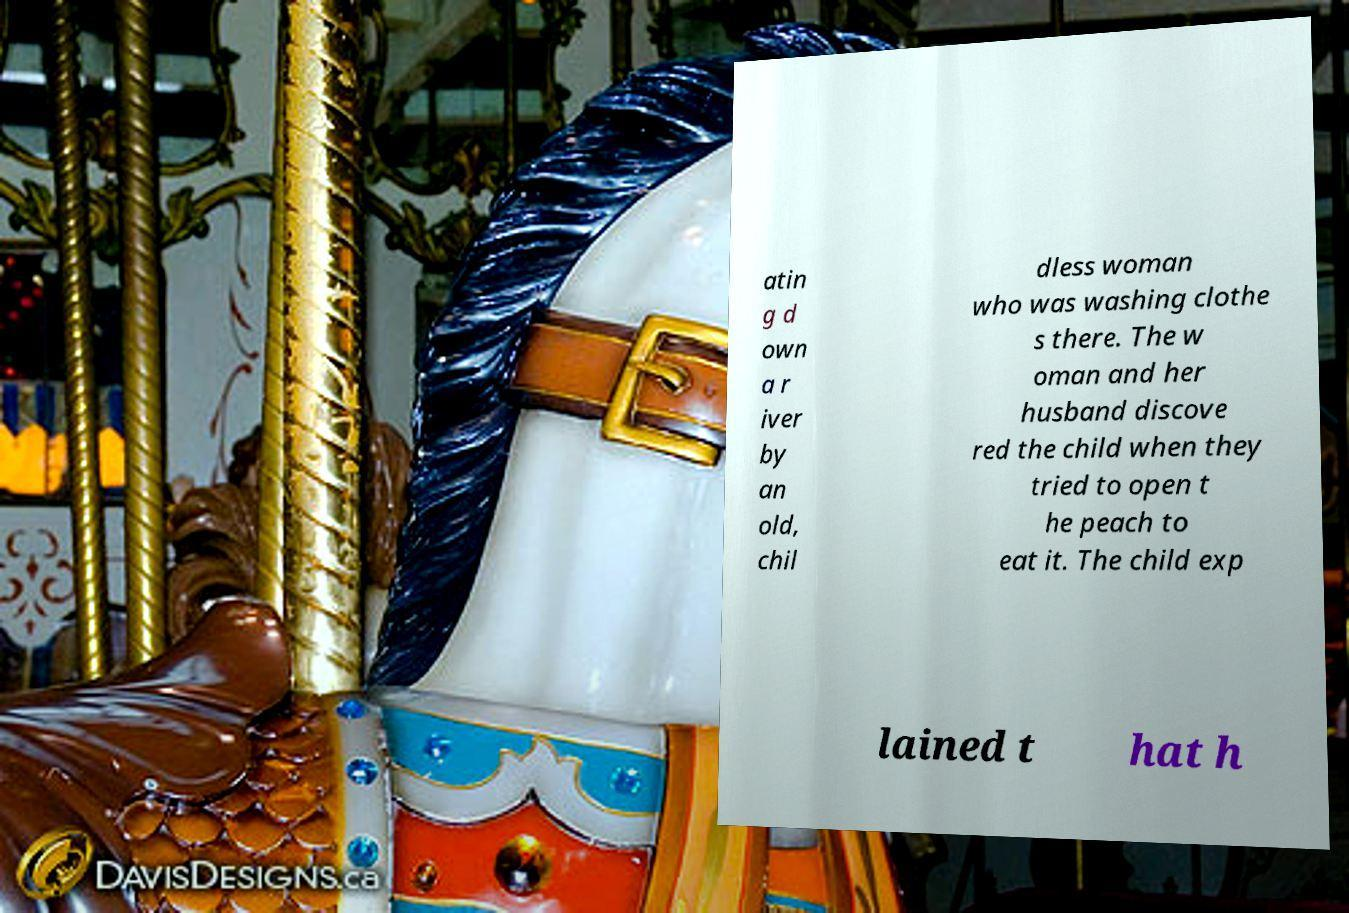Could you assist in decoding the text presented in this image and type it out clearly? atin g d own a r iver by an old, chil dless woman who was washing clothe s there. The w oman and her husband discove red the child when they tried to open t he peach to eat it. The child exp lained t hat h 